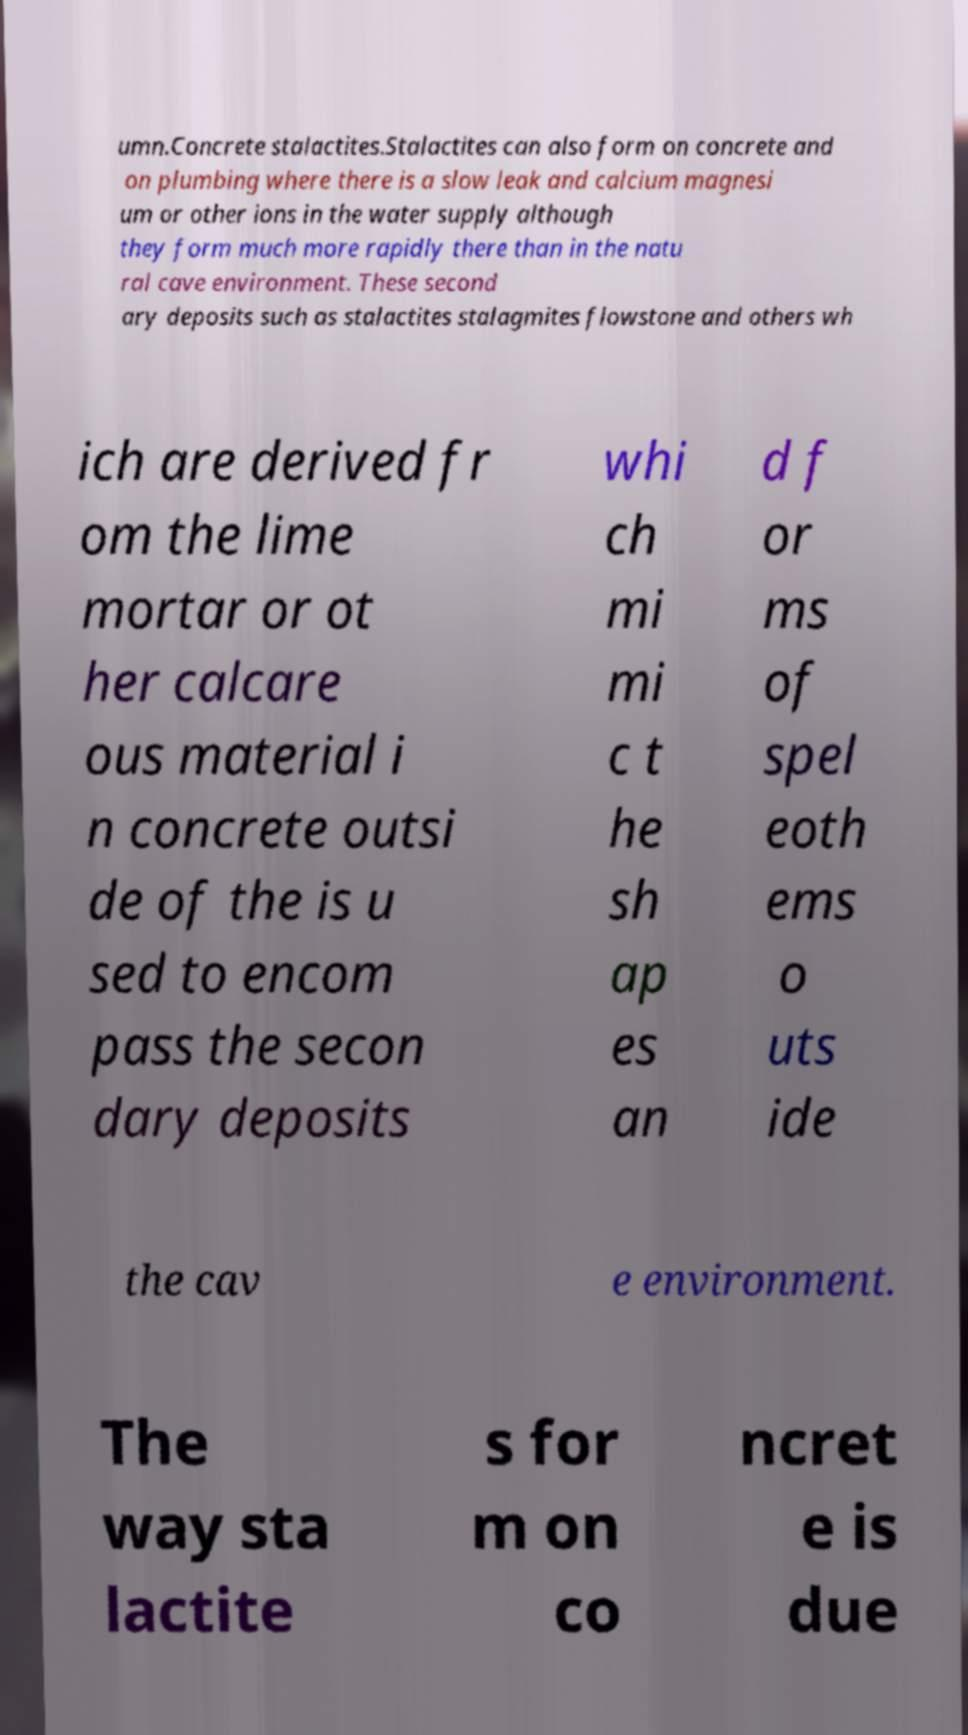For documentation purposes, I need the text within this image transcribed. Could you provide that? umn.Concrete stalactites.Stalactites can also form on concrete and on plumbing where there is a slow leak and calcium magnesi um or other ions in the water supply although they form much more rapidly there than in the natu ral cave environment. These second ary deposits such as stalactites stalagmites flowstone and others wh ich are derived fr om the lime mortar or ot her calcare ous material i n concrete outsi de of the is u sed to encom pass the secon dary deposits whi ch mi mi c t he sh ap es an d f or ms of spel eoth ems o uts ide the cav e environment. The way sta lactite s for m on co ncret e is due 